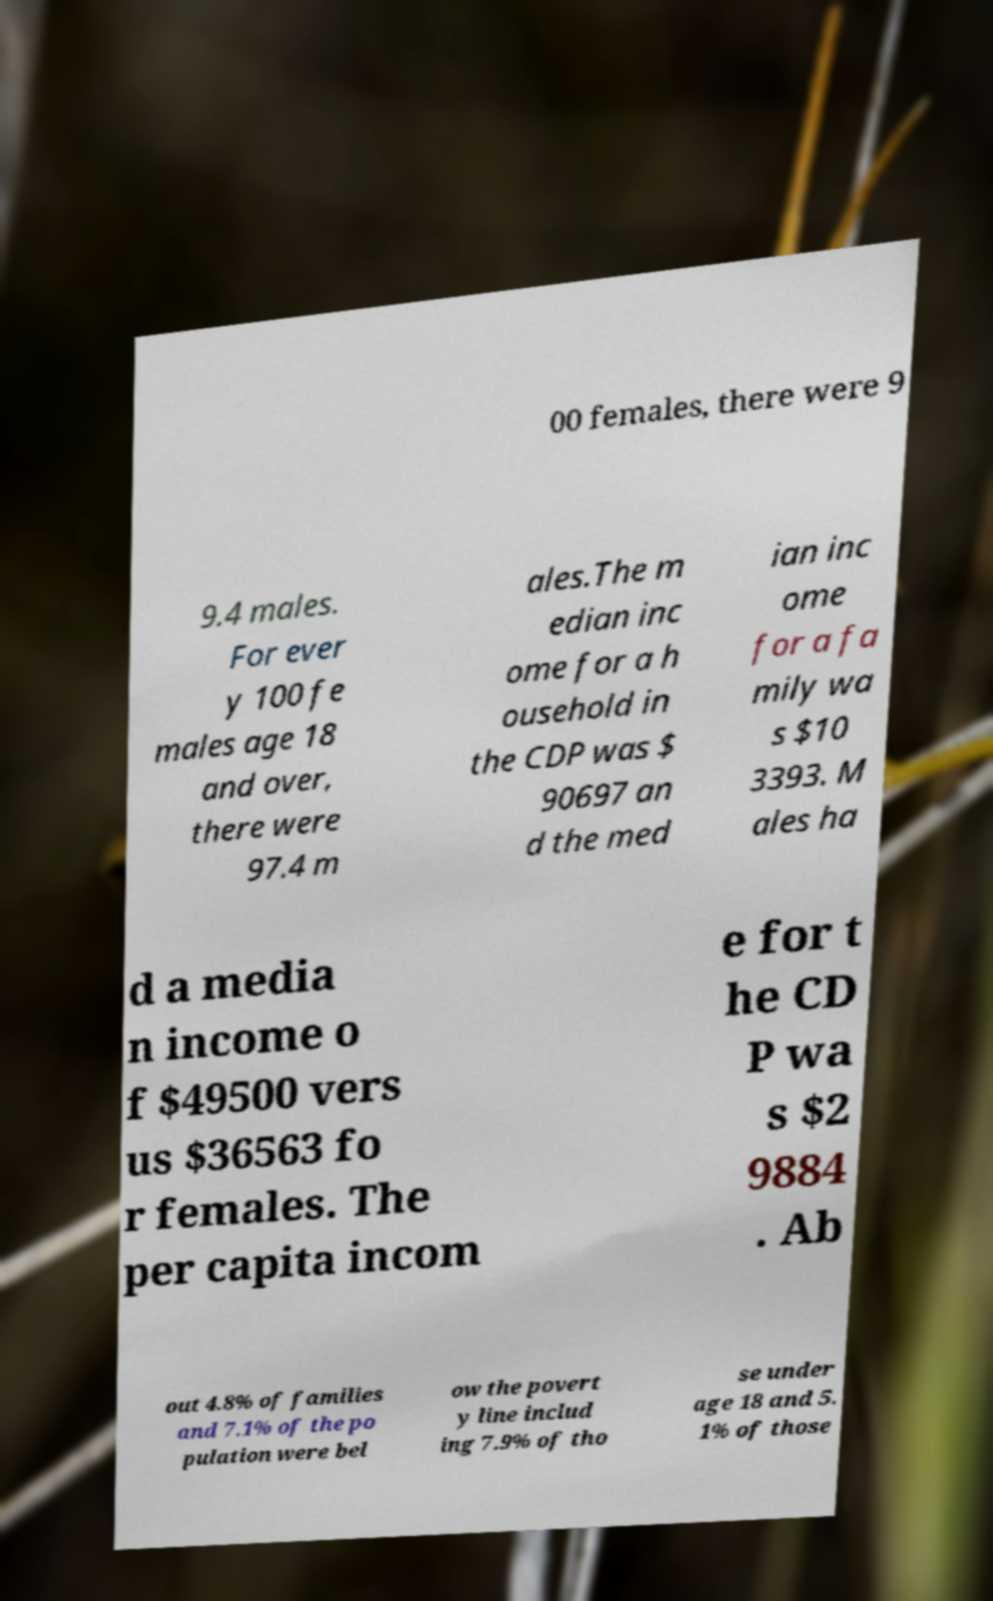For documentation purposes, I need the text within this image transcribed. Could you provide that? 00 females, there were 9 9.4 males. For ever y 100 fe males age 18 and over, there were 97.4 m ales.The m edian inc ome for a h ousehold in the CDP was $ 90697 an d the med ian inc ome for a fa mily wa s $10 3393. M ales ha d a media n income o f $49500 vers us $36563 fo r females. The per capita incom e for t he CD P wa s $2 9884 . Ab out 4.8% of families and 7.1% of the po pulation were bel ow the povert y line includ ing 7.9% of tho se under age 18 and 5. 1% of those 